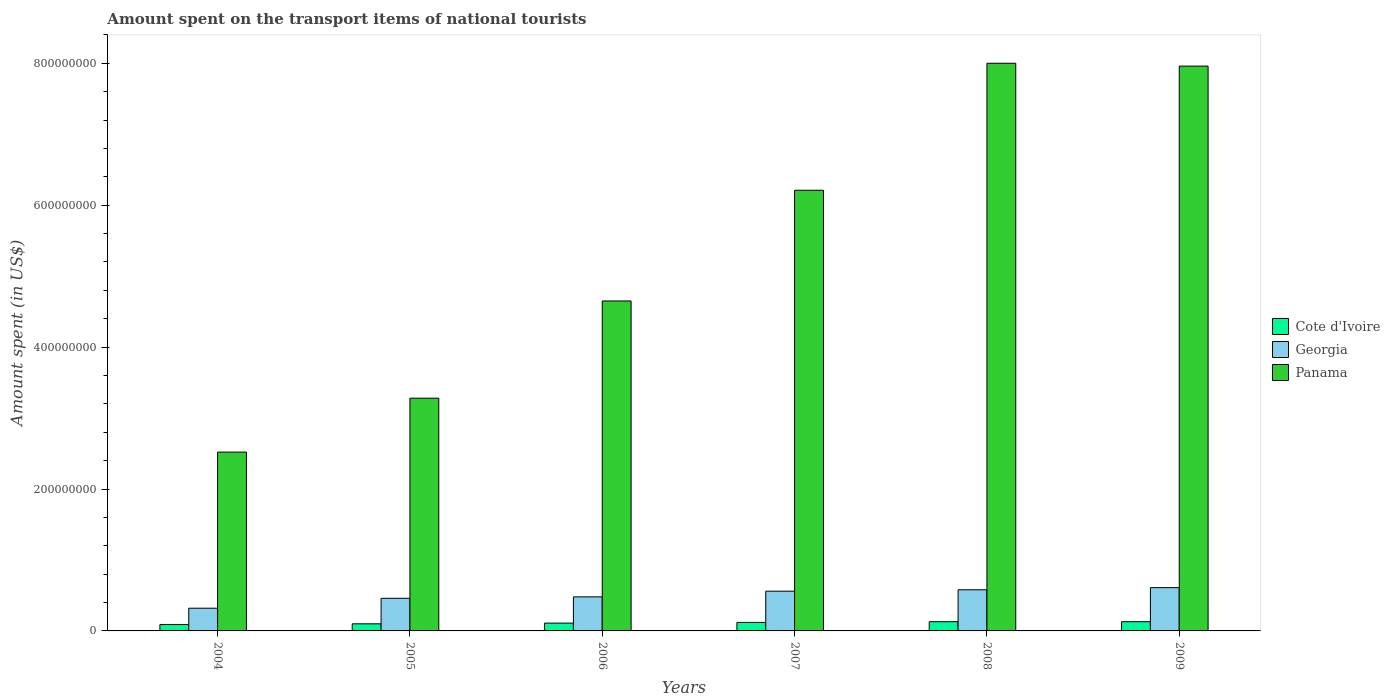How many different coloured bars are there?
Provide a short and direct response. 3. How many groups of bars are there?
Your answer should be compact. 6. Are the number of bars on each tick of the X-axis equal?
Your answer should be very brief. Yes. How many bars are there on the 4th tick from the right?
Make the answer very short. 3. What is the label of the 3rd group of bars from the left?
Offer a terse response. 2006. What is the amount spent on the transport items of national tourists in Georgia in 2006?
Keep it short and to the point. 4.80e+07. Across all years, what is the maximum amount spent on the transport items of national tourists in Georgia?
Offer a terse response. 6.10e+07. Across all years, what is the minimum amount spent on the transport items of national tourists in Georgia?
Your answer should be very brief. 3.20e+07. In which year was the amount spent on the transport items of national tourists in Cote d'Ivoire minimum?
Provide a short and direct response. 2004. What is the total amount spent on the transport items of national tourists in Georgia in the graph?
Give a very brief answer. 3.01e+08. What is the difference between the amount spent on the transport items of national tourists in Panama in 2007 and that in 2008?
Ensure brevity in your answer.  -1.79e+08. What is the difference between the amount spent on the transport items of national tourists in Georgia in 2008 and the amount spent on the transport items of national tourists in Cote d'Ivoire in 2004?
Offer a terse response. 4.90e+07. What is the average amount spent on the transport items of national tourists in Cote d'Ivoire per year?
Your answer should be compact. 1.13e+07. In the year 2004, what is the difference between the amount spent on the transport items of national tourists in Panama and amount spent on the transport items of national tourists in Georgia?
Provide a succinct answer. 2.20e+08. What is the ratio of the amount spent on the transport items of national tourists in Panama in 2005 to that in 2008?
Give a very brief answer. 0.41. What is the difference between the highest and the lowest amount spent on the transport items of national tourists in Georgia?
Give a very brief answer. 2.90e+07. In how many years, is the amount spent on the transport items of national tourists in Cote d'Ivoire greater than the average amount spent on the transport items of national tourists in Cote d'Ivoire taken over all years?
Your answer should be very brief. 3. What does the 1st bar from the left in 2004 represents?
Your answer should be compact. Cote d'Ivoire. What does the 2nd bar from the right in 2008 represents?
Offer a terse response. Georgia. How many bars are there?
Ensure brevity in your answer.  18. Are all the bars in the graph horizontal?
Offer a very short reply. No. How many years are there in the graph?
Ensure brevity in your answer.  6. Are the values on the major ticks of Y-axis written in scientific E-notation?
Provide a short and direct response. No. Where does the legend appear in the graph?
Offer a very short reply. Center right. What is the title of the graph?
Keep it short and to the point. Amount spent on the transport items of national tourists. What is the label or title of the X-axis?
Your answer should be compact. Years. What is the label or title of the Y-axis?
Give a very brief answer. Amount spent (in US$). What is the Amount spent (in US$) in Cote d'Ivoire in 2004?
Give a very brief answer. 9.00e+06. What is the Amount spent (in US$) of Georgia in 2004?
Provide a short and direct response. 3.20e+07. What is the Amount spent (in US$) in Panama in 2004?
Provide a short and direct response. 2.52e+08. What is the Amount spent (in US$) of Cote d'Ivoire in 2005?
Make the answer very short. 1.00e+07. What is the Amount spent (in US$) in Georgia in 2005?
Make the answer very short. 4.60e+07. What is the Amount spent (in US$) in Panama in 2005?
Offer a terse response. 3.28e+08. What is the Amount spent (in US$) in Cote d'Ivoire in 2006?
Ensure brevity in your answer.  1.10e+07. What is the Amount spent (in US$) in Georgia in 2006?
Offer a terse response. 4.80e+07. What is the Amount spent (in US$) in Panama in 2006?
Your answer should be very brief. 4.65e+08. What is the Amount spent (in US$) of Cote d'Ivoire in 2007?
Give a very brief answer. 1.20e+07. What is the Amount spent (in US$) of Georgia in 2007?
Offer a terse response. 5.60e+07. What is the Amount spent (in US$) of Panama in 2007?
Offer a terse response. 6.21e+08. What is the Amount spent (in US$) in Cote d'Ivoire in 2008?
Provide a succinct answer. 1.30e+07. What is the Amount spent (in US$) in Georgia in 2008?
Your answer should be compact. 5.80e+07. What is the Amount spent (in US$) in Panama in 2008?
Your answer should be compact. 8.00e+08. What is the Amount spent (in US$) in Cote d'Ivoire in 2009?
Make the answer very short. 1.30e+07. What is the Amount spent (in US$) in Georgia in 2009?
Provide a succinct answer. 6.10e+07. What is the Amount spent (in US$) of Panama in 2009?
Offer a terse response. 7.96e+08. Across all years, what is the maximum Amount spent (in US$) in Cote d'Ivoire?
Provide a succinct answer. 1.30e+07. Across all years, what is the maximum Amount spent (in US$) of Georgia?
Provide a succinct answer. 6.10e+07. Across all years, what is the maximum Amount spent (in US$) in Panama?
Offer a terse response. 8.00e+08. Across all years, what is the minimum Amount spent (in US$) of Cote d'Ivoire?
Make the answer very short. 9.00e+06. Across all years, what is the minimum Amount spent (in US$) of Georgia?
Your answer should be compact. 3.20e+07. Across all years, what is the minimum Amount spent (in US$) in Panama?
Your response must be concise. 2.52e+08. What is the total Amount spent (in US$) in Cote d'Ivoire in the graph?
Offer a very short reply. 6.80e+07. What is the total Amount spent (in US$) in Georgia in the graph?
Your answer should be very brief. 3.01e+08. What is the total Amount spent (in US$) of Panama in the graph?
Provide a succinct answer. 3.26e+09. What is the difference between the Amount spent (in US$) of Georgia in 2004 and that in 2005?
Offer a terse response. -1.40e+07. What is the difference between the Amount spent (in US$) of Panama in 2004 and that in 2005?
Your answer should be compact. -7.60e+07. What is the difference between the Amount spent (in US$) of Cote d'Ivoire in 2004 and that in 2006?
Your response must be concise. -2.00e+06. What is the difference between the Amount spent (in US$) in Georgia in 2004 and that in 2006?
Your answer should be compact. -1.60e+07. What is the difference between the Amount spent (in US$) of Panama in 2004 and that in 2006?
Offer a very short reply. -2.13e+08. What is the difference between the Amount spent (in US$) in Cote d'Ivoire in 2004 and that in 2007?
Your answer should be compact. -3.00e+06. What is the difference between the Amount spent (in US$) in Georgia in 2004 and that in 2007?
Offer a terse response. -2.40e+07. What is the difference between the Amount spent (in US$) in Panama in 2004 and that in 2007?
Offer a terse response. -3.69e+08. What is the difference between the Amount spent (in US$) in Cote d'Ivoire in 2004 and that in 2008?
Make the answer very short. -4.00e+06. What is the difference between the Amount spent (in US$) of Georgia in 2004 and that in 2008?
Your answer should be very brief. -2.60e+07. What is the difference between the Amount spent (in US$) in Panama in 2004 and that in 2008?
Provide a short and direct response. -5.48e+08. What is the difference between the Amount spent (in US$) of Cote d'Ivoire in 2004 and that in 2009?
Offer a terse response. -4.00e+06. What is the difference between the Amount spent (in US$) in Georgia in 2004 and that in 2009?
Offer a terse response. -2.90e+07. What is the difference between the Amount spent (in US$) of Panama in 2004 and that in 2009?
Offer a terse response. -5.44e+08. What is the difference between the Amount spent (in US$) in Georgia in 2005 and that in 2006?
Your answer should be very brief. -2.00e+06. What is the difference between the Amount spent (in US$) in Panama in 2005 and that in 2006?
Your answer should be very brief. -1.37e+08. What is the difference between the Amount spent (in US$) of Cote d'Ivoire in 2005 and that in 2007?
Offer a terse response. -2.00e+06. What is the difference between the Amount spent (in US$) of Georgia in 2005 and that in 2007?
Your answer should be compact. -1.00e+07. What is the difference between the Amount spent (in US$) of Panama in 2005 and that in 2007?
Make the answer very short. -2.93e+08. What is the difference between the Amount spent (in US$) in Georgia in 2005 and that in 2008?
Ensure brevity in your answer.  -1.20e+07. What is the difference between the Amount spent (in US$) of Panama in 2005 and that in 2008?
Offer a very short reply. -4.72e+08. What is the difference between the Amount spent (in US$) of Georgia in 2005 and that in 2009?
Give a very brief answer. -1.50e+07. What is the difference between the Amount spent (in US$) of Panama in 2005 and that in 2009?
Keep it short and to the point. -4.68e+08. What is the difference between the Amount spent (in US$) in Georgia in 2006 and that in 2007?
Provide a succinct answer. -8.00e+06. What is the difference between the Amount spent (in US$) in Panama in 2006 and that in 2007?
Make the answer very short. -1.56e+08. What is the difference between the Amount spent (in US$) in Cote d'Ivoire in 2006 and that in 2008?
Provide a succinct answer. -2.00e+06. What is the difference between the Amount spent (in US$) of Georgia in 2006 and that in 2008?
Offer a very short reply. -1.00e+07. What is the difference between the Amount spent (in US$) in Panama in 2006 and that in 2008?
Offer a terse response. -3.35e+08. What is the difference between the Amount spent (in US$) of Georgia in 2006 and that in 2009?
Your answer should be compact. -1.30e+07. What is the difference between the Amount spent (in US$) in Panama in 2006 and that in 2009?
Keep it short and to the point. -3.31e+08. What is the difference between the Amount spent (in US$) of Georgia in 2007 and that in 2008?
Provide a short and direct response. -2.00e+06. What is the difference between the Amount spent (in US$) in Panama in 2007 and that in 2008?
Provide a short and direct response. -1.79e+08. What is the difference between the Amount spent (in US$) of Cote d'Ivoire in 2007 and that in 2009?
Ensure brevity in your answer.  -1.00e+06. What is the difference between the Amount spent (in US$) of Georgia in 2007 and that in 2009?
Offer a terse response. -5.00e+06. What is the difference between the Amount spent (in US$) in Panama in 2007 and that in 2009?
Your answer should be compact. -1.75e+08. What is the difference between the Amount spent (in US$) of Georgia in 2008 and that in 2009?
Offer a terse response. -3.00e+06. What is the difference between the Amount spent (in US$) of Panama in 2008 and that in 2009?
Offer a terse response. 4.00e+06. What is the difference between the Amount spent (in US$) of Cote d'Ivoire in 2004 and the Amount spent (in US$) of Georgia in 2005?
Provide a succinct answer. -3.70e+07. What is the difference between the Amount spent (in US$) of Cote d'Ivoire in 2004 and the Amount spent (in US$) of Panama in 2005?
Your answer should be compact. -3.19e+08. What is the difference between the Amount spent (in US$) of Georgia in 2004 and the Amount spent (in US$) of Panama in 2005?
Provide a succinct answer. -2.96e+08. What is the difference between the Amount spent (in US$) in Cote d'Ivoire in 2004 and the Amount spent (in US$) in Georgia in 2006?
Provide a short and direct response. -3.90e+07. What is the difference between the Amount spent (in US$) in Cote d'Ivoire in 2004 and the Amount spent (in US$) in Panama in 2006?
Your answer should be very brief. -4.56e+08. What is the difference between the Amount spent (in US$) of Georgia in 2004 and the Amount spent (in US$) of Panama in 2006?
Offer a very short reply. -4.33e+08. What is the difference between the Amount spent (in US$) of Cote d'Ivoire in 2004 and the Amount spent (in US$) of Georgia in 2007?
Provide a short and direct response. -4.70e+07. What is the difference between the Amount spent (in US$) of Cote d'Ivoire in 2004 and the Amount spent (in US$) of Panama in 2007?
Your response must be concise. -6.12e+08. What is the difference between the Amount spent (in US$) in Georgia in 2004 and the Amount spent (in US$) in Panama in 2007?
Your answer should be compact. -5.89e+08. What is the difference between the Amount spent (in US$) of Cote d'Ivoire in 2004 and the Amount spent (in US$) of Georgia in 2008?
Keep it short and to the point. -4.90e+07. What is the difference between the Amount spent (in US$) of Cote d'Ivoire in 2004 and the Amount spent (in US$) of Panama in 2008?
Your response must be concise. -7.91e+08. What is the difference between the Amount spent (in US$) in Georgia in 2004 and the Amount spent (in US$) in Panama in 2008?
Keep it short and to the point. -7.68e+08. What is the difference between the Amount spent (in US$) in Cote d'Ivoire in 2004 and the Amount spent (in US$) in Georgia in 2009?
Offer a very short reply. -5.20e+07. What is the difference between the Amount spent (in US$) of Cote d'Ivoire in 2004 and the Amount spent (in US$) of Panama in 2009?
Offer a terse response. -7.87e+08. What is the difference between the Amount spent (in US$) in Georgia in 2004 and the Amount spent (in US$) in Panama in 2009?
Offer a very short reply. -7.64e+08. What is the difference between the Amount spent (in US$) of Cote d'Ivoire in 2005 and the Amount spent (in US$) of Georgia in 2006?
Offer a terse response. -3.80e+07. What is the difference between the Amount spent (in US$) of Cote d'Ivoire in 2005 and the Amount spent (in US$) of Panama in 2006?
Provide a succinct answer. -4.55e+08. What is the difference between the Amount spent (in US$) in Georgia in 2005 and the Amount spent (in US$) in Panama in 2006?
Provide a succinct answer. -4.19e+08. What is the difference between the Amount spent (in US$) in Cote d'Ivoire in 2005 and the Amount spent (in US$) in Georgia in 2007?
Ensure brevity in your answer.  -4.60e+07. What is the difference between the Amount spent (in US$) in Cote d'Ivoire in 2005 and the Amount spent (in US$) in Panama in 2007?
Provide a short and direct response. -6.11e+08. What is the difference between the Amount spent (in US$) in Georgia in 2005 and the Amount spent (in US$) in Panama in 2007?
Provide a short and direct response. -5.75e+08. What is the difference between the Amount spent (in US$) of Cote d'Ivoire in 2005 and the Amount spent (in US$) of Georgia in 2008?
Keep it short and to the point. -4.80e+07. What is the difference between the Amount spent (in US$) in Cote d'Ivoire in 2005 and the Amount spent (in US$) in Panama in 2008?
Offer a very short reply. -7.90e+08. What is the difference between the Amount spent (in US$) in Georgia in 2005 and the Amount spent (in US$) in Panama in 2008?
Offer a very short reply. -7.54e+08. What is the difference between the Amount spent (in US$) of Cote d'Ivoire in 2005 and the Amount spent (in US$) of Georgia in 2009?
Provide a succinct answer. -5.10e+07. What is the difference between the Amount spent (in US$) of Cote d'Ivoire in 2005 and the Amount spent (in US$) of Panama in 2009?
Your answer should be very brief. -7.86e+08. What is the difference between the Amount spent (in US$) of Georgia in 2005 and the Amount spent (in US$) of Panama in 2009?
Your answer should be compact. -7.50e+08. What is the difference between the Amount spent (in US$) of Cote d'Ivoire in 2006 and the Amount spent (in US$) of Georgia in 2007?
Give a very brief answer. -4.50e+07. What is the difference between the Amount spent (in US$) of Cote d'Ivoire in 2006 and the Amount spent (in US$) of Panama in 2007?
Your answer should be compact. -6.10e+08. What is the difference between the Amount spent (in US$) in Georgia in 2006 and the Amount spent (in US$) in Panama in 2007?
Ensure brevity in your answer.  -5.73e+08. What is the difference between the Amount spent (in US$) in Cote d'Ivoire in 2006 and the Amount spent (in US$) in Georgia in 2008?
Give a very brief answer. -4.70e+07. What is the difference between the Amount spent (in US$) in Cote d'Ivoire in 2006 and the Amount spent (in US$) in Panama in 2008?
Your answer should be compact. -7.89e+08. What is the difference between the Amount spent (in US$) of Georgia in 2006 and the Amount spent (in US$) of Panama in 2008?
Keep it short and to the point. -7.52e+08. What is the difference between the Amount spent (in US$) in Cote d'Ivoire in 2006 and the Amount spent (in US$) in Georgia in 2009?
Keep it short and to the point. -5.00e+07. What is the difference between the Amount spent (in US$) of Cote d'Ivoire in 2006 and the Amount spent (in US$) of Panama in 2009?
Your answer should be very brief. -7.85e+08. What is the difference between the Amount spent (in US$) of Georgia in 2006 and the Amount spent (in US$) of Panama in 2009?
Offer a terse response. -7.48e+08. What is the difference between the Amount spent (in US$) in Cote d'Ivoire in 2007 and the Amount spent (in US$) in Georgia in 2008?
Keep it short and to the point. -4.60e+07. What is the difference between the Amount spent (in US$) of Cote d'Ivoire in 2007 and the Amount spent (in US$) of Panama in 2008?
Ensure brevity in your answer.  -7.88e+08. What is the difference between the Amount spent (in US$) of Georgia in 2007 and the Amount spent (in US$) of Panama in 2008?
Provide a succinct answer. -7.44e+08. What is the difference between the Amount spent (in US$) in Cote d'Ivoire in 2007 and the Amount spent (in US$) in Georgia in 2009?
Your answer should be very brief. -4.90e+07. What is the difference between the Amount spent (in US$) in Cote d'Ivoire in 2007 and the Amount spent (in US$) in Panama in 2009?
Provide a succinct answer. -7.84e+08. What is the difference between the Amount spent (in US$) of Georgia in 2007 and the Amount spent (in US$) of Panama in 2009?
Offer a very short reply. -7.40e+08. What is the difference between the Amount spent (in US$) in Cote d'Ivoire in 2008 and the Amount spent (in US$) in Georgia in 2009?
Offer a terse response. -4.80e+07. What is the difference between the Amount spent (in US$) in Cote d'Ivoire in 2008 and the Amount spent (in US$) in Panama in 2009?
Offer a terse response. -7.83e+08. What is the difference between the Amount spent (in US$) of Georgia in 2008 and the Amount spent (in US$) of Panama in 2009?
Your answer should be very brief. -7.38e+08. What is the average Amount spent (in US$) in Cote d'Ivoire per year?
Offer a terse response. 1.13e+07. What is the average Amount spent (in US$) in Georgia per year?
Make the answer very short. 5.02e+07. What is the average Amount spent (in US$) of Panama per year?
Provide a succinct answer. 5.44e+08. In the year 2004, what is the difference between the Amount spent (in US$) of Cote d'Ivoire and Amount spent (in US$) of Georgia?
Give a very brief answer. -2.30e+07. In the year 2004, what is the difference between the Amount spent (in US$) in Cote d'Ivoire and Amount spent (in US$) in Panama?
Provide a succinct answer. -2.43e+08. In the year 2004, what is the difference between the Amount spent (in US$) of Georgia and Amount spent (in US$) of Panama?
Provide a succinct answer. -2.20e+08. In the year 2005, what is the difference between the Amount spent (in US$) in Cote d'Ivoire and Amount spent (in US$) in Georgia?
Provide a succinct answer. -3.60e+07. In the year 2005, what is the difference between the Amount spent (in US$) in Cote d'Ivoire and Amount spent (in US$) in Panama?
Offer a terse response. -3.18e+08. In the year 2005, what is the difference between the Amount spent (in US$) of Georgia and Amount spent (in US$) of Panama?
Make the answer very short. -2.82e+08. In the year 2006, what is the difference between the Amount spent (in US$) in Cote d'Ivoire and Amount spent (in US$) in Georgia?
Give a very brief answer. -3.70e+07. In the year 2006, what is the difference between the Amount spent (in US$) in Cote d'Ivoire and Amount spent (in US$) in Panama?
Offer a very short reply. -4.54e+08. In the year 2006, what is the difference between the Amount spent (in US$) of Georgia and Amount spent (in US$) of Panama?
Your answer should be very brief. -4.17e+08. In the year 2007, what is the difference between the Amount spent (in US$) of Cote d'Ivoire and Amount spent (in US$) of Georgia?
Offer a terse response. -4.40e+07. In the year 2007, what is the difference between the Amount spent (in US$) of Cote d'Ivoire and Amount spent (in US$) of Panama?
Offer a terse response. -6.09e+08. In the year 2007, what is the difference between the Amount spent (in US$) in Georgia and Amount spent (in US$) in Panama?
Provide a short and direct response. -5.65e+08. In the year 2008, what is the difference between the Amount spent (in US$) of Cote d'Ivoire and Amount spent (in US$) of Georgia?
Your response must be concise. -4.50e+07. In the year 2008, what is the difference between the Amount spent (in US$) of Cote d'Ivoire and Amount spent (in US$) of Panama?
Provide a succinct answer. -7.87e+08. In the year 2008, what is the difference between the Amount spent (in US$) in Georgia and Amount spent (in US$) in Panama?
Your answer should be very brief. -7.42e+08. In the year 2009, what is the difference between the Amount spent (in US$) of Cote d'Ivoire and Amount spent (in US$) of Georgia?
Offer a terse response. -4.80e+07. In the year 2009, what is the difference between the Amount spent (in US$) in Cote d'Ivoire and Amount spent (in US$) in Panama?
Provide a short and direct response. -7.83e+08. In the year 2009, what is the difference between the Amount spent (in US$) of Georgia and Amount spent (in US$) of Panama?
Provide a short and direct response. -7.35e+08. What is the ratio of the Amount spent (in US$) in Georgia in 2004 to that in 2005?
Provide a short and direct response. 0.7. What is the ratio of the Amount spent (in US$) in Panama in 2004 to that in 2005?
Provide a short and direct response. 0.77. What is the ratio of the Amount spent (in US$) in Cote d'Ivoire in 2004 to that in 2006?
Give a very brief answer. 0.82. What is the ratio of the Amount spent (in US$) in Panama in 2004 to that in 2006?
Your response must be concise. 0.54. What is the ratio of the Amount spent (in US$) in Georgia in 2004 to that in 2007?
Offer a very short reply. 0.57. What is the ratio of the Amount spent (in US$) of Panama in 2004 to that in 2007?
Your answer should be very brief. 0.41. What is the ratio of the Amount spent (in US$) in Cote d'Ivoire in 2004 to that in 2008?
Provide a short and direct response. 0.69. What is the ratio of the Amount spent (in US$) in Georgia in 2004 to that in 2008?
Your answer should be compact. 0.55. What is the ratio of the Amount spent (in US$) of Panama in 2004 to that in 2008?
Offer a terse response. 0.32. What is the ratio of the Amount spent (in US$) in Cote d'Ivoire in 2004 to that in 2009?
Give a very brief answer. 0.69. What is the ratio of the Amount spent (in US$) of Georgia in 2004 to that in 2009?
Your answer should be very brief. 0.52. What is the ratio of the Amount spent (in US$) of Panama in 2004 to that in 2009?
Your response must be concise. 0.32. What is the ratio of the Amount spent (in US$) of Georgia in 2005 to that in 2006?
Provide a short and direct response. 0.96. What is the ratio of the Amount spent (in US$) of Panama in 2005 to that in 2006?
Offer a very short reply. 0.71. What is the ratio of the Amount spent (in US$) in Georgia in 2005 to that in 2007?
Provide a succinct answer. 0.82. What is the ratio of the Amount spent (in US$) in Panama in 2005 to that in 2007?
Give a very brief answer. 0.53. What is the ratio of the Amount spent (in US$) in Cote d'Ivoire in 2005 to that in 2008?
Your answer should be very brief. 0.77. What is the ratio of the Amount spent (in US$) in Georgia in 2005 to that in 2008?
Make the answer very short. 0.79. What is the ratio of the Amount spent (in US$) of Panama in 2005 to that in 2008?
Offer a terse response. 0.41. What is the ratio of the Amount spent (in US$) of Cote d'Ivoire in 2005 to that in 2009?
Offer a terse response. 0.77. What is the ratio of the Amount spent (in US$) in Georgia in 2005 to that in 2009?
Your answer should be compact. 0.75. What is the ratio of the Amount spent (in US$) in Panama in 2005 to that in 2009?
Offer a terse response. 0.41. What is the ratio of the Amount spent (in US$) in Panama in 2006 to that in 2007?
Ensure brevity in your answer.  0.75. What is the ratio of the Amount spent (in US$) of Cote d'Ivoire in 2006 to that in 2008?
Give a very brief answer. 0.85. What is the ratio of the Amount spent (in US$) of Georgia in 2006 to that in 2008?
Provide a short and direct response. 0.83. What is the ratio of the Amount spent (in US$) in Panama in 2006 to that in 2008?
Your answer should be compact. 0.58. What is the ratio of the Amount spent (in US$) of Cote d'Ivoire in 2006 to that in 2009?
Give a very brief answer. 0.85. What is the ratio of the Amount spent (in US$) of Georgia in 2006 to that in 2009?
Ensure brevity in your answer.  0.79. What is the ratio of the Amount spent (in US$) in Panama in 2006 to that in 2009?
Ensure brevity in your answer.  0.58. What is the ratio of the Amount spent (in US$) of Cote d'Ivoire in 2007 to that in 2008?
Your response must be concise. 0.92. What is the ratio of the Amount spent (in US$) of Georgia in 2007 to that in 2008?
Offer a terse response. 0.97. What is the ratio of the Amount spent (in US$) in Panama in 2007 to that in 2008?
Your answer should be compact. 0.78. What is the ratio of the Amount spent (in US$) of Cote d'Ivoire in 2007 to that in 2009?
Your response must be concise. 0.92. What is the ratio of the Amount spent (in US$) in Georgia in 2007 to that in 2009?
Offer a terse response. 0.92. What is the ratio of the Amount spent (in US$) of Panama in 2007 to that in 2009?
Provide a short and direct response. 0.78. What is the ratio of the Amount spent (in US$) in Cote d'Ivoire in 2008 to that in 2009?
Offer a very short reply. 1. What is the ratio of the Amount spent (in US$) of Georgia in 2008 to that in 2009?
Keep it short and to the point. 0.95. What is the ratio of the Amount spent (in US$) of Panama in 2008 to that in 2009?
Offer a terse response. 1. What is the difference between the highest and the second highest Amount spent (in US$) of Cote d'Ivoire?
Provide a short and direct response. 0. What is the difference between the highest and the lowest Amount spent (in US$) in Georgia?
Your response must be concise. 2.90e+07. What is the difference between the highest and the lowest Amount spent (in US$) of Panama?
Your response must be concise. 5.48e+08. 